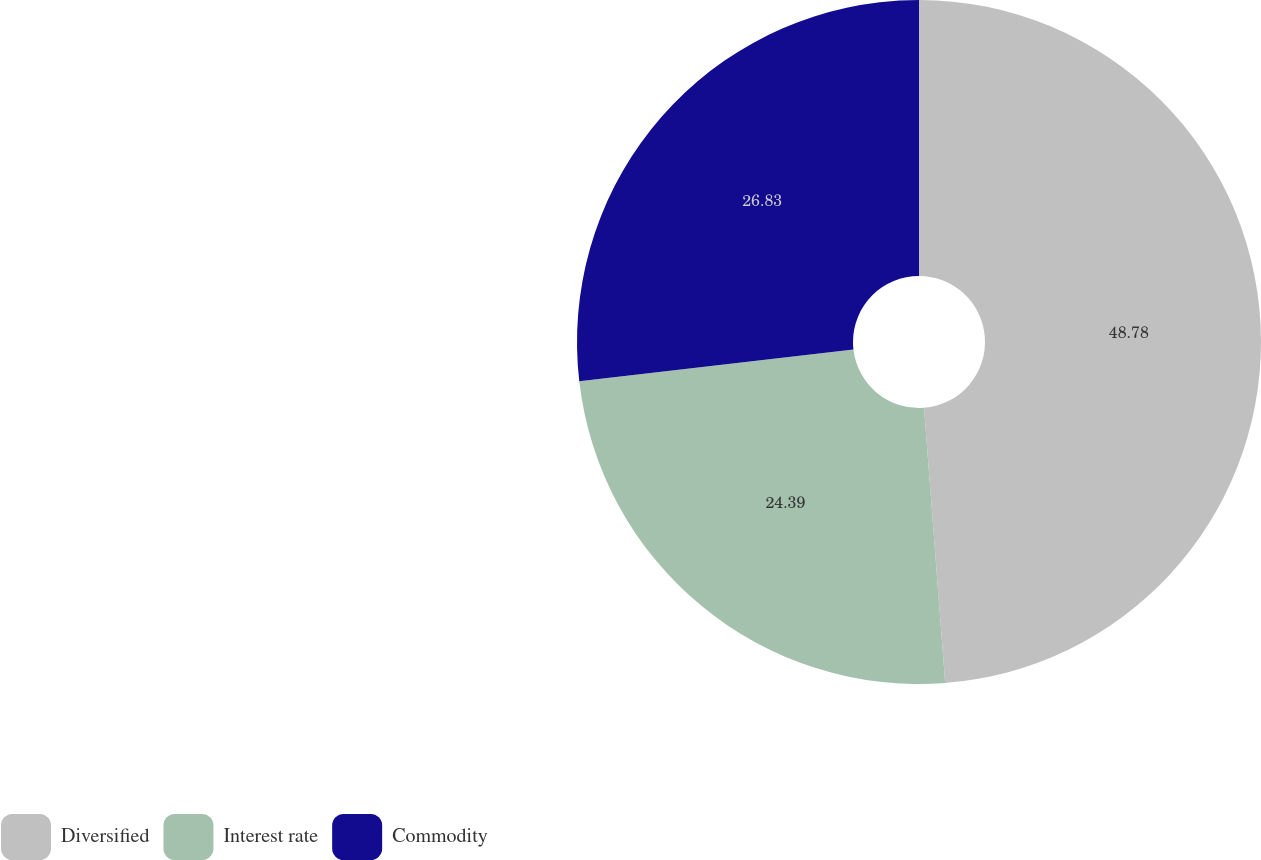<chart> <loc_0><loc_0><loc_500><loc_500><pie_chart><fcel>Diversified<fcel>Interest rate<fcel>Commodity<nl><fcel>48.78%<fcel>24.39%<fcel>26.83%<nl></chart> 